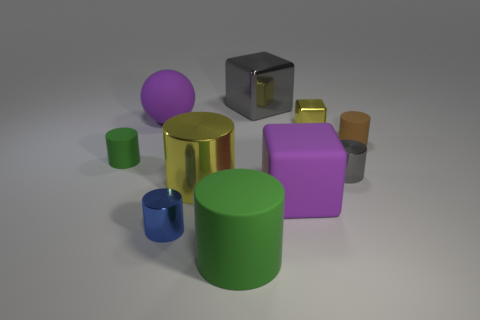There is a thing that is the same color as the large shiny cube; what material is it?
Make the answer very short. Metal. Is there anything else that has the same size as the gray block?
Keep it short and to the point. Yes. There is a matte block that is the same color as the matte ball; what is its size?
Your answer should be very brief. Large. How many cubes are either large blue rubber objects or blue objects?
Keep it short and to the point. 0. Are there more cylinders than big purple matte spheres?
Give a very brief answer. Yes. How many gray shiny cylinders are the same size as the blue shiny cylinder?
Offer a very short reply. 1. What shape is the shiny object that is the same color as the large metal cylinder?
Ensure brevity in your answer.  Cube. What number of objects are either metal objects behind the small green rubber thing or cylinders?
Offer a terse response. 8. Are there fewer gray metal cylinders than blocks?
Offer a terse response. Yes. The brown thing that is the same material as the big sphere is what shape?
Provide a short and direct response. Cylinder. 